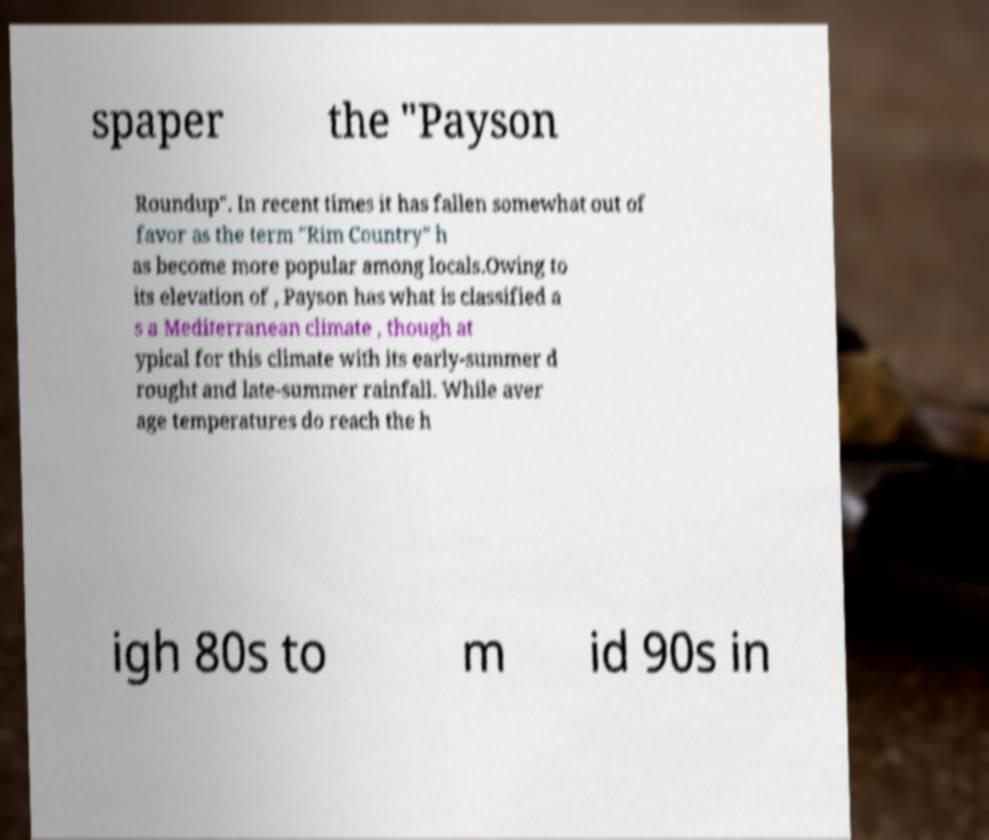Could you extract and type out the text from this image? spaper the "Payson Roundup". In recent times it has fallen somewhat out of favor as the term "Rim Country" h as become more popular among locals.Owing to its elevation of , Payson has what is classified a s a Mediterranean climate , though at ypical for this climate with its early-summer d rought and late-summer rainfall. While aver age temperatures do reach the h igh 80s to m id 90s in 